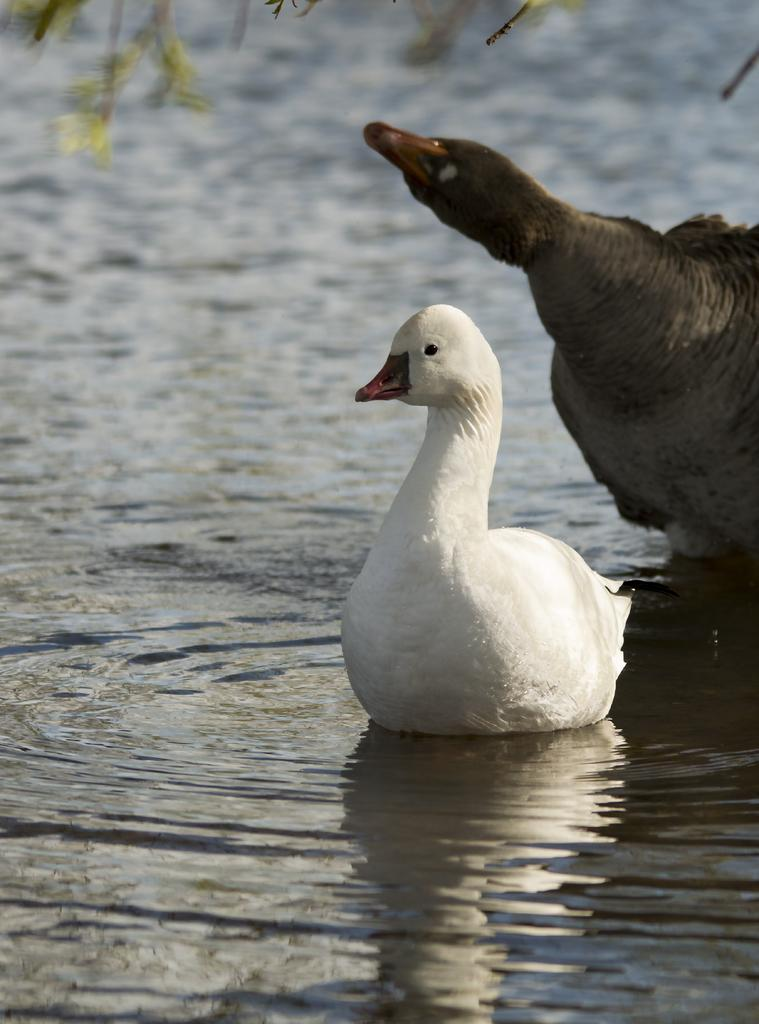What animals can be seen in the image? There are birds on the water in the image. What is the primary element in which the birds are situated? The birds are situated on the water in the image. What can be seen at the top of the image? There are branches visible at the top of the image. How many cherries are hanging from the branches in the image? There are no cherries present in the image; only birds and water are visible. 